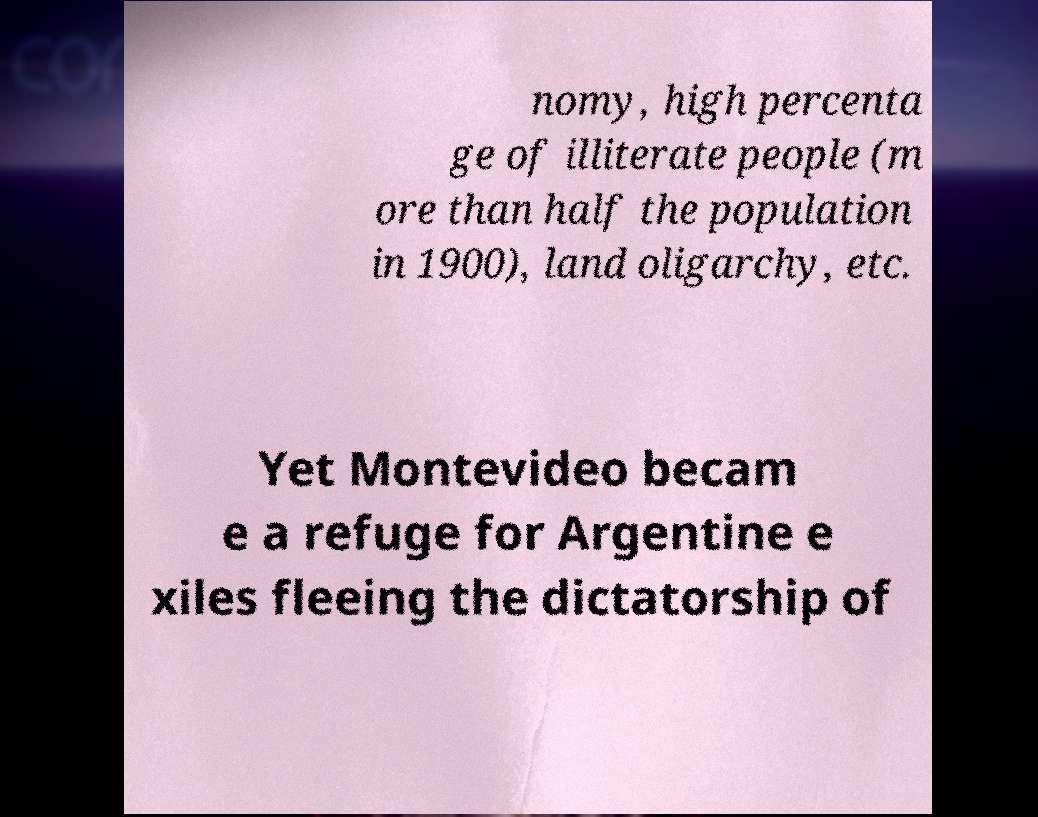There's text embedded in this image that I need extracted. Can you transcribe it verbatim? nomy, high percenta ge of illiterate people (m ore than half the population in 1900), land oligarchy, etc. Yet Montevideo becam e a refuge for Argentine e xiles fleeing the dictatorship of 